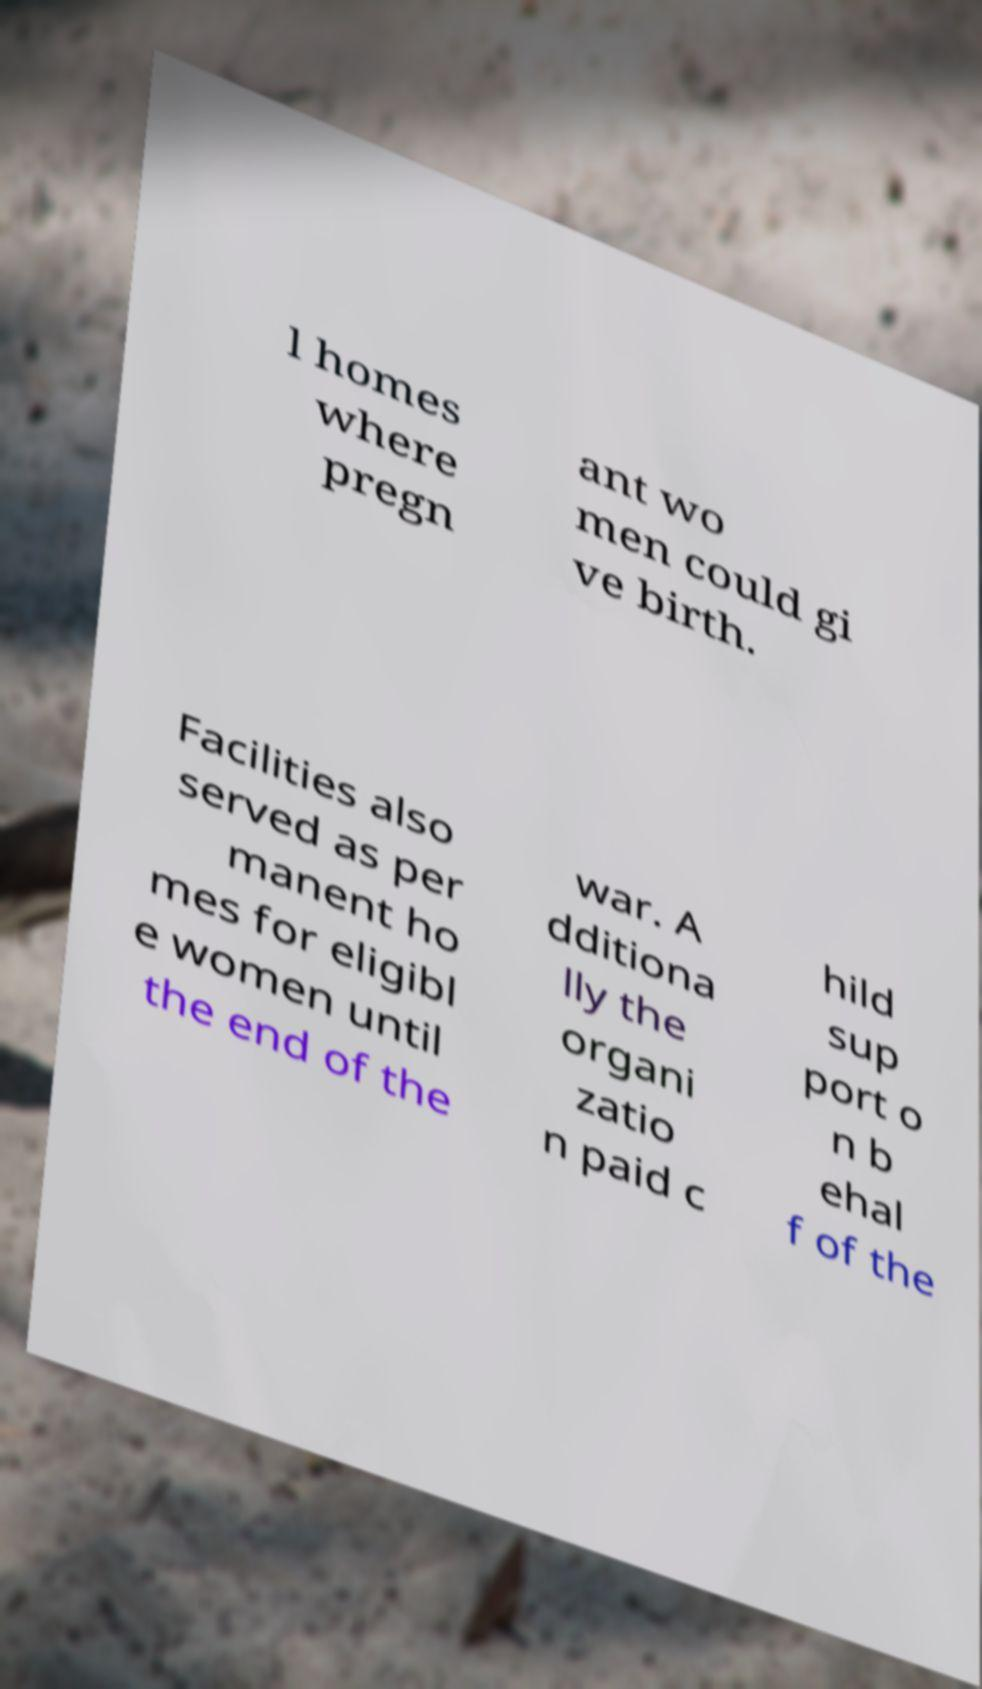Could you assist in decoding the text presented in this image and type it out clearly? l homes where pregn ant wo men could gi ve birth. Facilities also served as per manent ho mes for eligibl e women until the end of the war. A dditiona lly the organi zatio n paid c hild sup port o n b ehal f of the 